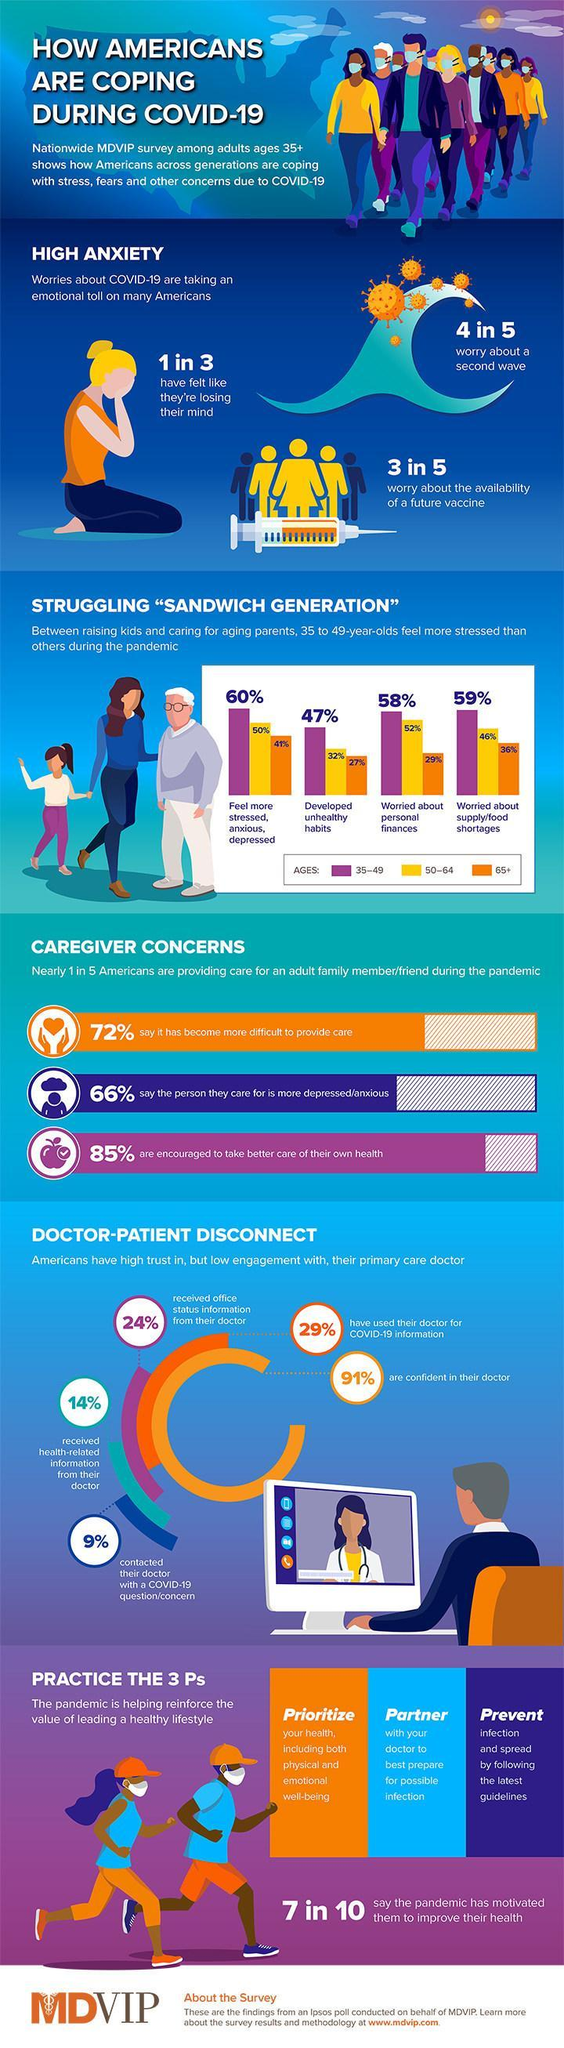Which age group people in America felt less stressed & depressed than others during the COVID-19 pandemic as per the MDVIP survey?
Answer the question with a short phrase. 65+ What percentage of Americans aged 65+ years were worried about their personal finances during the COVID-19 pandemic as per the MDVIP survey? 29% What percentage of Americans aged 50-64 years old were worried about their personal finances during the COVID-19 pandemic as per the MDVIP survey? 52% What percentage of Americans aged 35-49 years old were worried about the supply or food shortages during the COVID-19 pandemic as per the MDVIP survey? 59% What percent of patients in America are not confident about their doctor during the COVID-19 pandemic according to the MDVIP survey? 9% What percentage of Americans aged 50-64 years old developed unhealthy habits during the COVID-19 pandemic as per the MDVIP survey? 32% What percent of patients in America contacted their doctor with a COVID-19 question or concern according to the MDVIP survey? 9% What percent of patients in America received health related information from their doctor during the COVID-19 pandemic according to the MDVIP survey? 14% 